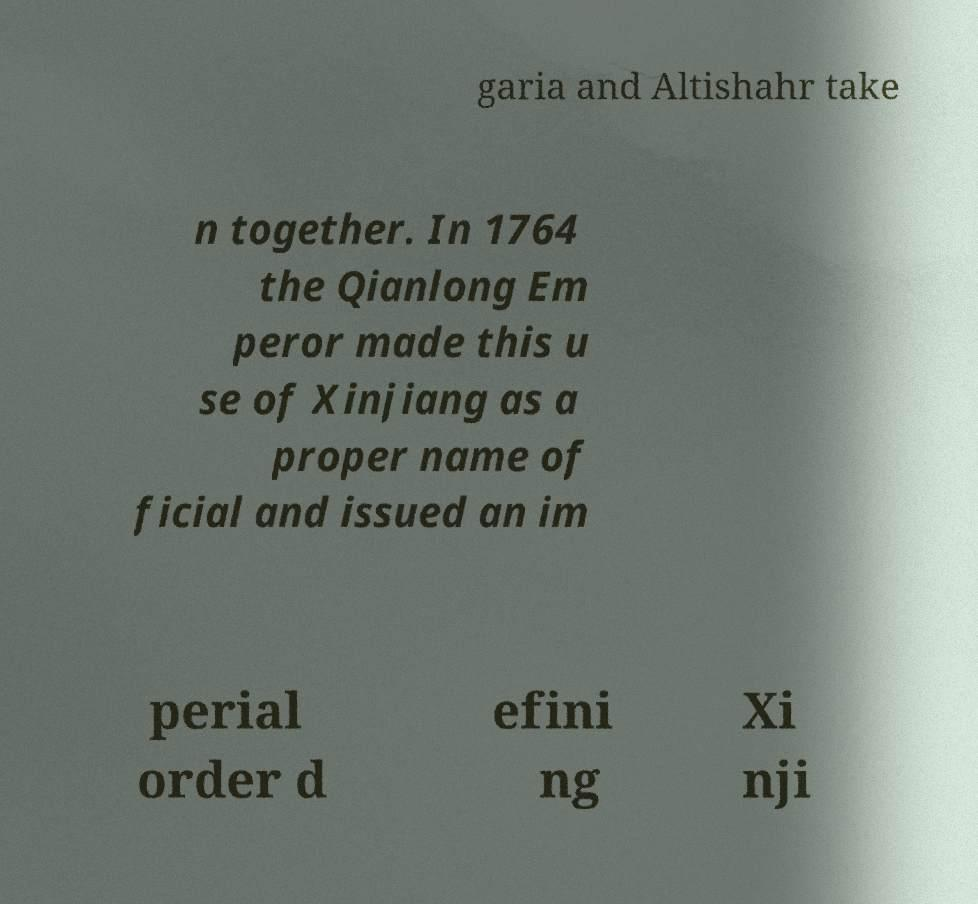Can you accurately transcribe the text from the provided image for me? garia and Altishahr take n together. In 1764 the Qianlong Em peror made this u se of Xinjiang as a proper name of ficial and issued an im perial order d efini ng Xi nji 